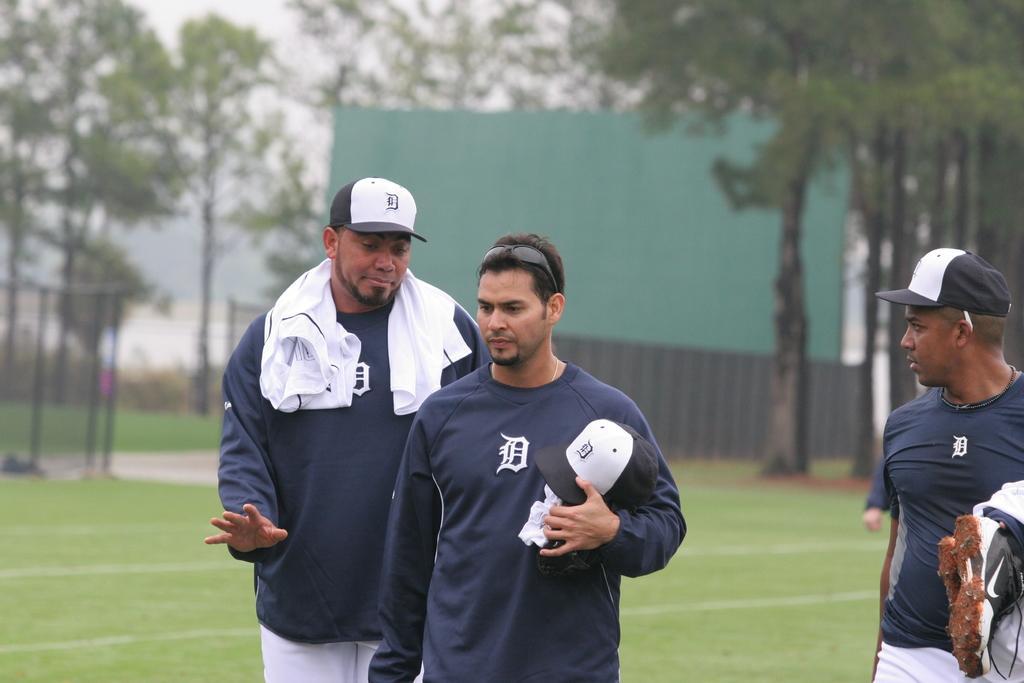Describe this image in one or two sentences. In the middle of the image few people are standing. Behind them there is grass and there are some trees. 